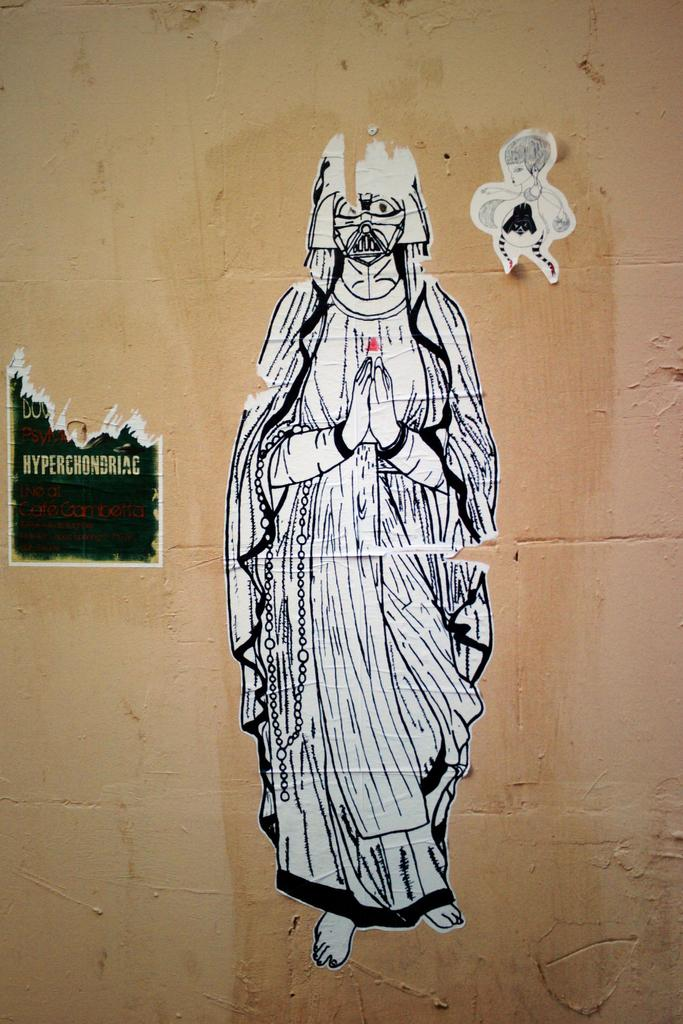What is depicted on the poster in the image? There is a poster of a person in the image. How would you describe the condition of the person's poster? The poster of the person is teared. Are there any other posters visible in the image? Yes, there are other posters on the wall in the image. What type of nation is depicted on the poster? There is no nation depicted on the poster; it features a person. What kind of engine can be seen powering the structure in the image? There is no structure or engine present in the image; it only contains posters on a wall. 